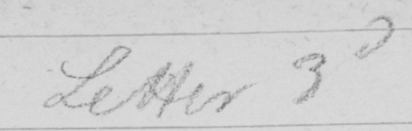Please provide the text content of this handwritten line. Letter 3d 